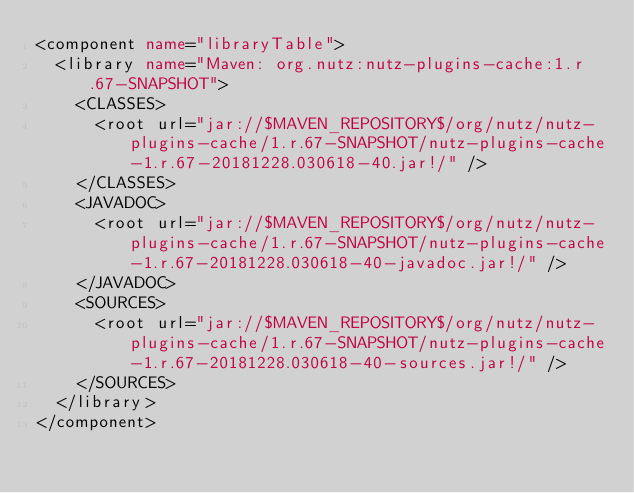<code> <loc_0><loc_0><loc_500><loc_500><_XML_><component name="libraryTable">
  <library name="Maven: org.nutz:nutz-plugins-cache:1.r.67-SNAPSHOT">
    <CLASSES>
      <root url="jar://$MAVEN_REPOSITORY$/org/nutz/nutz-plugins-cache/1.r.67-SNAPSHOT/nutz-plugins-cache-1.r.67-20181228.030618-40.jar!/" />
    </CLASSES>
    <JAVADOC>
      <root url="jar://$MAVEN_REPOSITORY$/org/nutz/nutz-plugins-cache/1.r.67-SNAPSHOT/nutz-plugins-cache-1.r.67-20181228.030618-40-javadoc.jar!/" />
    </JAVADOC>
    <SOURCES>
      <root url="jar://$MAVEN_REPOSITORY$/org/nutz/nutz-plugins-cache/1.r.67-SNAPSHOT/nutz-plugins-cache-1.r.67-20181228.030618-40-sources.jar!/" />
    </SOURCES>
  </library>
</component></code> 